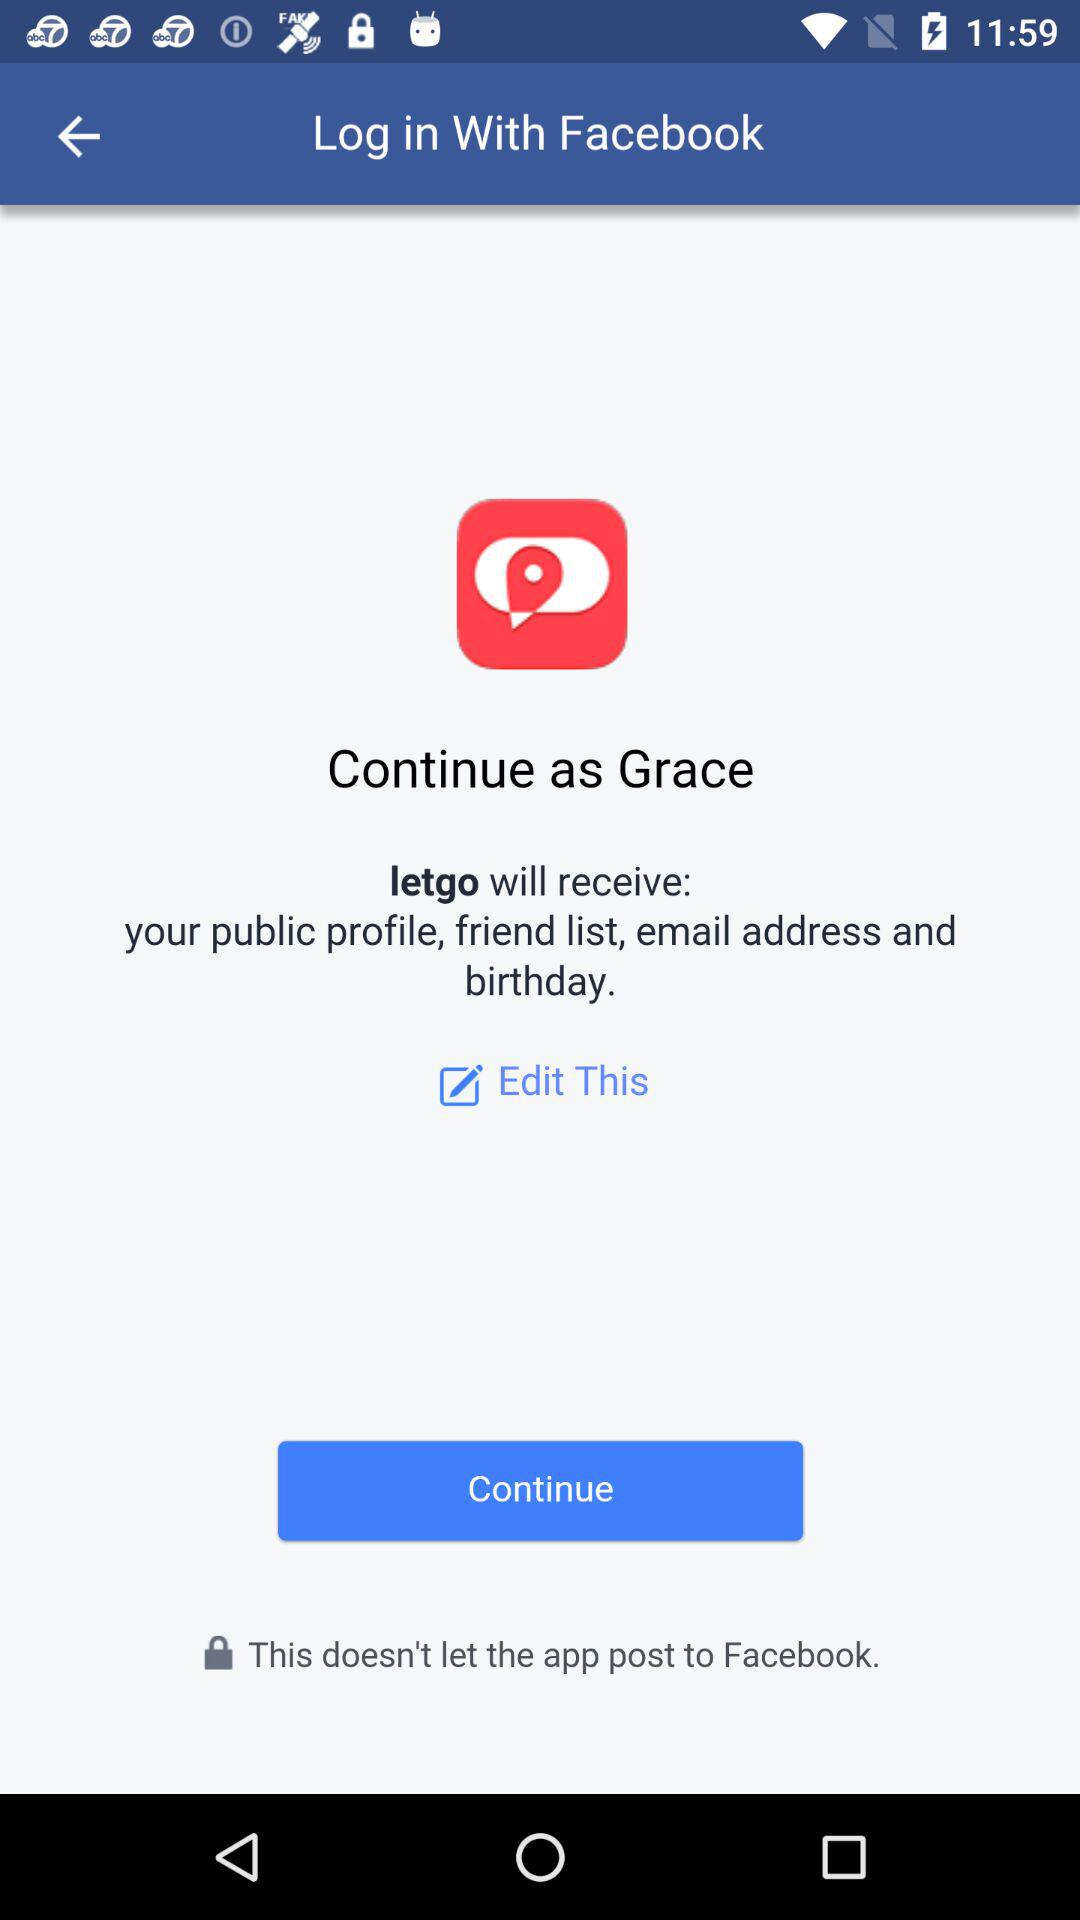What is the name of the user? The name of the user is Grace. 